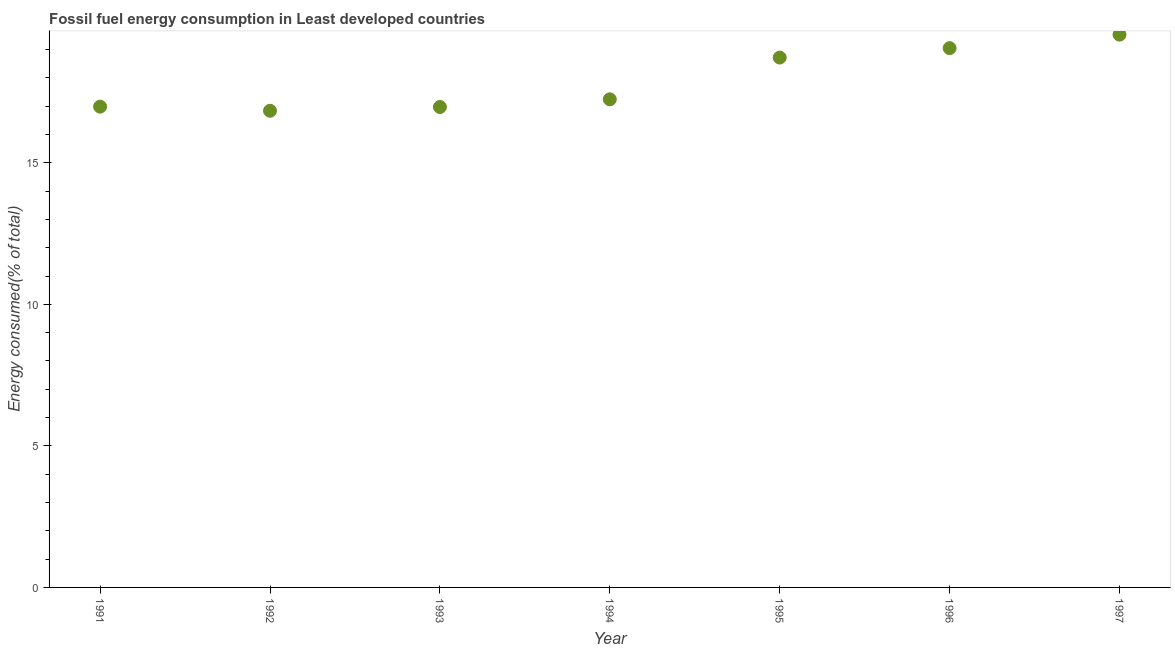What is the fossil fuel energy consumption in 1993?
Give a very brief answer. 16.97. Across all years, what is the maximum fossil fuel energy consumption?
Offer a very short reply. 19.53. Across all years, what is the minimum fossil fuel energy consumption?
Provide a succinct answer. 16.84. In which year was the fossil fuel energy consumption maximum?
Offer a terse response. 1997. What is the sum of the fossil fuel energy consumption?
Offer a terse response. 125.35. What is the difference between the fossil fuel energy consumption in 1992 and 1994?
Your answer should be very brief. -0.4. What is the average fossil fuel energy consumption per year?
Make the answer very short. 17.91. What is the median fossil fuel energy consumption?
Make the answer very short. 17.25. Do a majority of the years between 1996 and 1993 (inclusive) have fossil fuel energy consumption greater than 18 %?
Offer a very short reply. Yes. What is the ratio of the fossil fuel energy consumption in 1992 to that in 1996?
Keep it short and to the point. 0.88. Is the difference between the fossil fuel energy consumption in 1994 and 1995 greater than the difference between any two years?
Your response must be concise. No. What is the difference between the highest and the second highest fossil fuel energy consumption?
Your answer should be very brief. 0.48. What is the difference between the highest and the lowest fossil fuel energy consumption?
Provide a short and direct response. 2.69. In how many years, is the fossil fuel energy consumption greater than the average fossil fuel energy consumption taken over all years?
Provide a succinct answer. 3. Does the fossil fuel energy consumption monotonically increase over the years?
Provide a succinct answer. No. How many dotlines are there?
Your response must be concise. 1. What is the difference between two consecutive major ticks on the Y-axis?
Offer a terse response. 5. Are the values on the major ticks of Y-axis written in scientific E-notation?
Make the answer very short. No. Does the graph contain any zero values?
Offer a very short reply. No. Does the graph contain grids?
Make the answer very short. No. What is the title of the graph?
Offer a very short reply. Fossil fuel energy consumption in Least developed countries. What is the label or title of the X-axis?
Your response must be concise. Year. What is the label or title of the Y-axis?
Provide a short and direct response. Energy consumed(% of total). What is the Energy consumed(% of total) in 1991?
Ensure brevity in your answer.  16.99. What is the Energy consumed(% of total) in 1992?
Offer a terse response. 16.84. What is the Energy consumed(% of total) in 1993?
Make the answer very short. 16.97. What is the Energy consumed(% of total) in 1994?
Offer a very short reply. 17.25. What is the Energy consumed(% of total) in 1995?
Provide a short and direct response. 18.72. What is the Energy consumed(% of total) in 1996?
Offer a very short reply. 19.05. What is the Energy consumed(% of total) in 1997?
Your answer should be compact. 19.53. What is the difference between the Energy consumed(% of total) in 1991 and 1992?
Offer a very short reply. 0.15. What is the difference between the Energy consumed(% of total) in 1991 and 1993?
Give a very brief answer. 0.01. What is the difference between the Energy consumed(% of total) in 1991 and 1994?
Provide a succinct answer. -0.26. What is the difference between the Energy consumed(% of total) in 1991 and 1995?
Make the answer very short. -1.73. What is the difference between the Energy consumed(% of total) in 1991 and 1996?
Make the answer very short. -2.07. What is the difference between the Energy consumed(% of total) in 1991 and 1997?
Your answer should be compact. -2.54. What is the difference between the Energy consumed(% of total) in 1992 and 1993?
Provide a succinct answer. -0.13. What is the difference between the Energy consumed(% of total) in 1992 and 1994?
Your response must be concise. -0.4. What is the difference between the Energy consumed(% of total) in 1992 and 1995?
Ensure brevity in your answer.  -1.88. What is the difference between the Energy consumed(% of total) in 1992 and 1996?
Your answer should be very brief. -2.21. What is the difference between the Energy consumed(% of total) in 1992 and 1997?
Make the answer very short. -2.69. What is the difference between the Energy consumed(% of total) in 1993 and 1994?
Give a very brief answer. -0.27. What is the difference between the Energy consumed(% of total) in 1993 and 1995?
Ensure brevity in your answer.  -1.75. What is the difference between the Energy consumed(% of total) in 1993 and 1996?
Keep it short and to the point. -2.08. What is the difference between the Energy consumed(% of total) in 1993 and 1997?
Offer a very short reply. -2.56. What is the difference between the Energy consumed(% of total) in 1994 and 1995?
Make the answer very short. -1.48. What is the difference between the Energy consumed(% of total) in 1994 and 1996?
Offer a very short reply. -1.81. What is the difference between the Energy consumed(% of total) in 1994 and 1997?
Your answer should be very brief. -2.29. What is the difference between the Energy consumed(% of total) in 1995 and 1996?
Keep it short and to the point. -0.33. What is the difference between the Energy consumed(% of total) in 1995 and 1997?
Your response must be concise. -0.81. What is the difference between the Energy consumed(% of total) in 1996 and 1997?
Offer a terse response. -0.48. What is the ratio of the Energy consumed(% of total) in 1991 to that in 1992?
Make the answer very short. 1.01. What is the ratio of the Energy consumed(% of total) in 1991 to that in 1993?
Give a very brief answer. 1. What is the ratio of the Energy consumed(% of total) in 1991 to that in 1994?
Your response must be concise. 0.98. What is the ratio of the Energy consumed(% of total) in 1991 to that in 1995?
Provide a succinct answer. 0.91. What is the ratio of the Energy consumed(% of total) in 1991 to that in 1996?
Make the answer very short. 0.89. What is the ratio of the Energy consumed(% of total) in 1991 to that in 1997?
Provide a short and direct response. 0.87. What is the ratio of the Energy consumed(% of total) in 1992 to that in 1993?
Provide a succinct answer. 0.99. What is the ratio of the Energy consumed(% of total) in 1992 to that in 1996?
Ensure brevity in your answer.  0.88. What is the ratio of the Energy consumed(% of total) in 1992 to that in 1997?
Keep it short and to the point. 0.86. What is the ratio of the Energy consumed(% of total) in 1993 to that in 1995?
Give a very brief answer. 0.91. What is the ratio of the Energy consumed(% of total) in 1993 to that in 1996?
Give a very brief answer. 0.89. What is the ratio of the Energy consumed(% of total) in 1993 to that in 1997?
Your answer should be compact. 0.87. What is the ratio of the Energy consumed(% of total) in 1994 to that in 1995?
Offer a terse response. 0.92. What is the ratio of the Energy consumed(% of total) in 1994 to that in 1996?
Your answer should be compact. 0.91. What is the ratio of the Energy consumed(% of total) in 1994 to that in 1997?
Your response must be concise. 0.88. What is the ratio of the Energy consumed(% of total) in 1995 to that in 1997?
Offer a terse response. 0.96. 